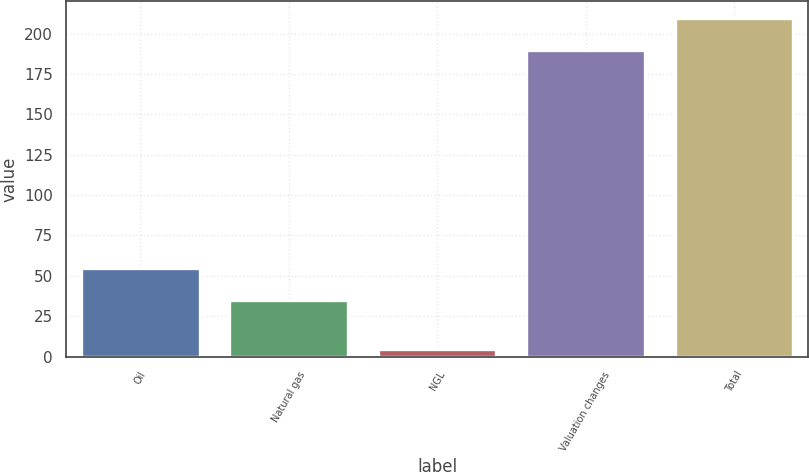Convert chart. <chart><loc_0><loc_0><loc_500><loc_500><bar_chart><fcel>Oil<fcel>Natural gas<fcel>NGL<fcel>Valuation changes<fcel>Total<nl><fcel>54.6<fcel>35<fcel>5<fcel>190<fcel>209.6<nl></chart> 